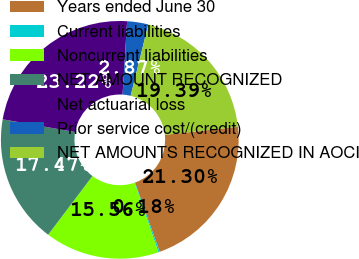Convert chart to OTSL. <chart><loc_0><loc_0><loc_500><loc_500><pie_chart><fcel>Years ended June 30<fcel>Current liabilities<fcel>Noncurrent liabilities<fcel>NET AMOUNT RECOGNIZED<fcel>Net actuarial loss<fcel>Prior service cost/(credit)<fcel>NET AMOUNTS RECOGNIZED IN AOCI<nl><fcel>21.3%<fcel>0.18%<fcel>15.56%<fcel>17.47%<fcel>23.22%<fcel>2.87%<fcel>19.39%<nl></chart> 